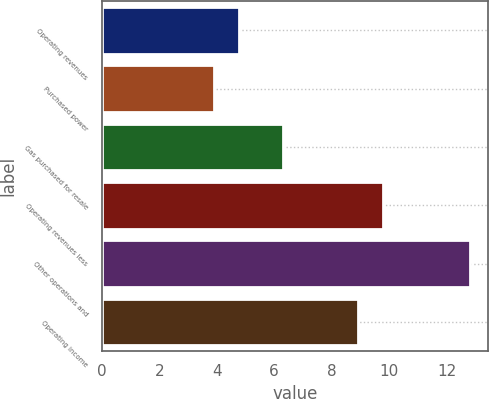<chart> <loc_0><loc_0><loc_500><loc_500><bar_chart><fcel>Operating revenues<fcel>Purchased power<fcel>Gas purchased for resale<fcel>Operating revenues less<fcel>Other operations and<fcel>Operating income<nl><fcel>4.79<fcel>3.9<fcel>6.3<fcel>9.79<fcel>12.8<fcel>8.9<nl></chart> 